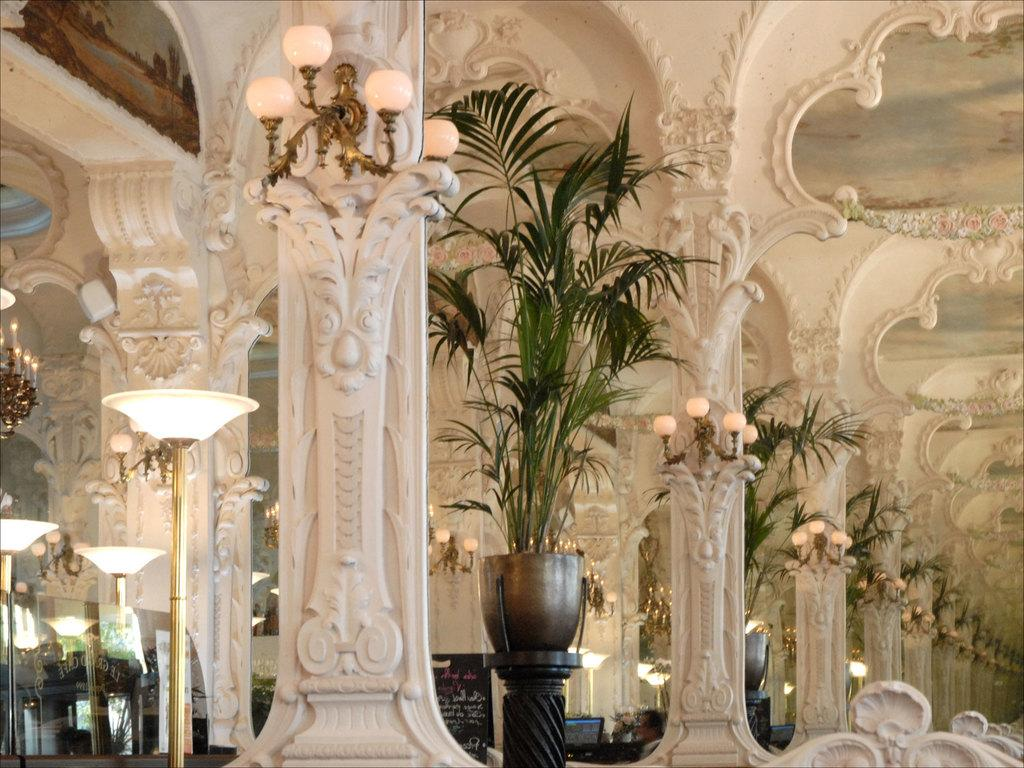What type of objects can be seen in the image that provide illumination? There are lights in the image. What architectural features are present in the image? There are pillars in the image. What type of vegetation is visible in the image? There are plants in the image. What can be read or observed on a flat surface in the image? There is a board with text in the image. Can you hear the band playing in the image? There is no band present in the image, so it is not possible to hear them playing. What type of work are the laborers doing in the image? There are no laborers present in the image, so it is not possible to describe their work. 